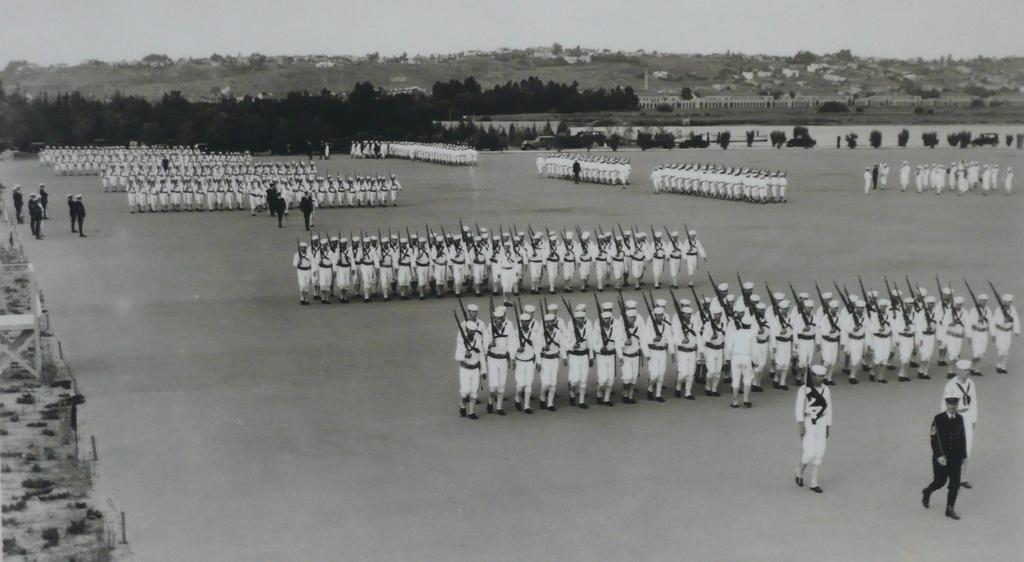What are the people in the image doing? The people in the image are standing and holding guns. What is the position of the guns in the image? The guns are on the ground. What can be seen in the background of the image? There are trees, buildings, and the sky visible in the background of the image. What type of corn is being harvested in the image? There is no corn present in the image; it features people standing with guns and a background of trees, buildings, and the sky. 